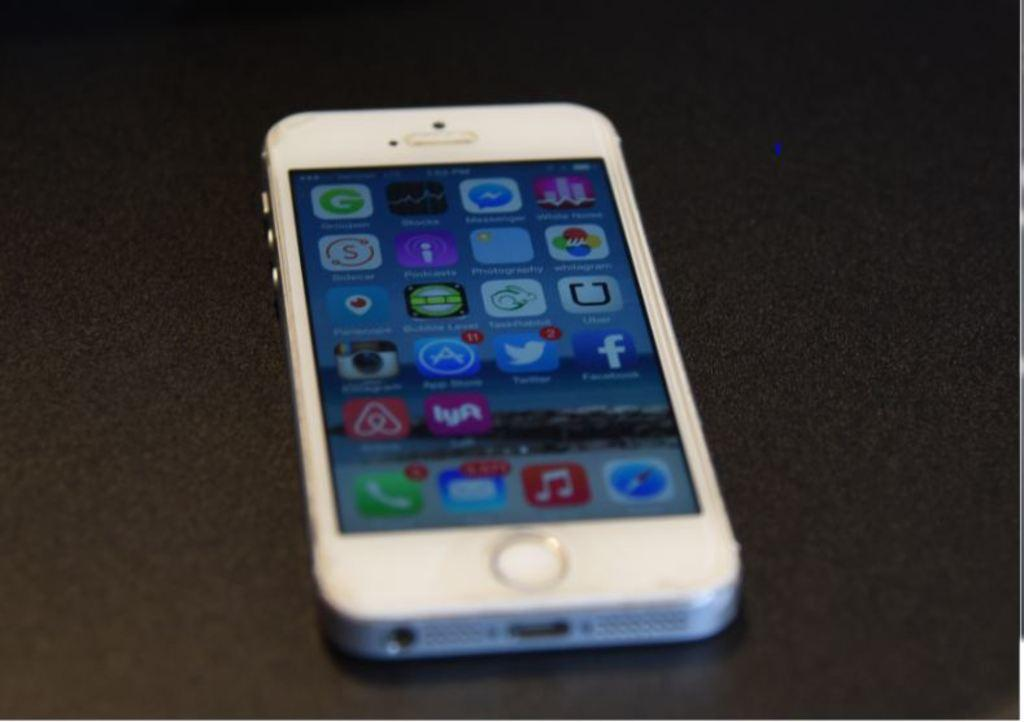Provide a one-sentence caption for the provided image. Iphone with the home screen showing missed calls and apps. 